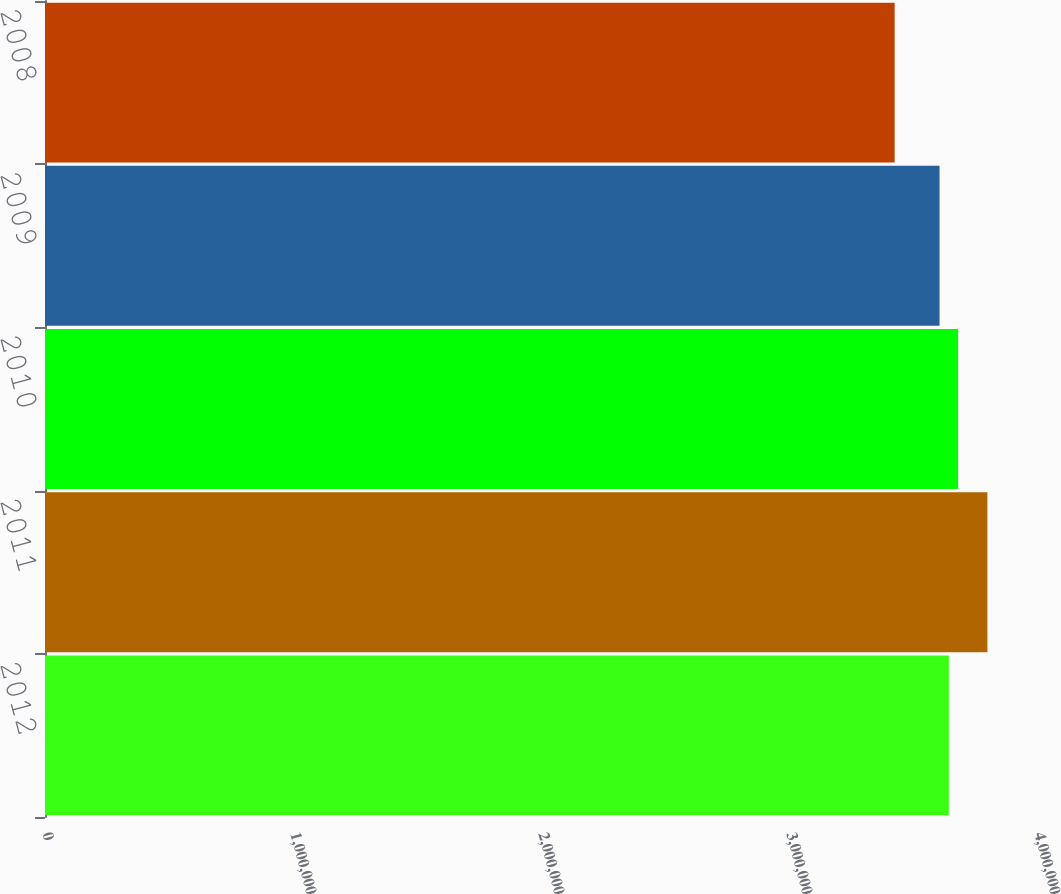<chart> <loc_0><loc_0><loc_500><loc_500><bar_chart><fcel>2012<fcel>2011<fcel>2010<fcel>2009<fcel>2008<nl><fcel>3.6444e+06<fcel>3.8e+06<fcel>3.6818e+06<fcel>3.607e+06<fcel>3.426e+06<nl></chart> 